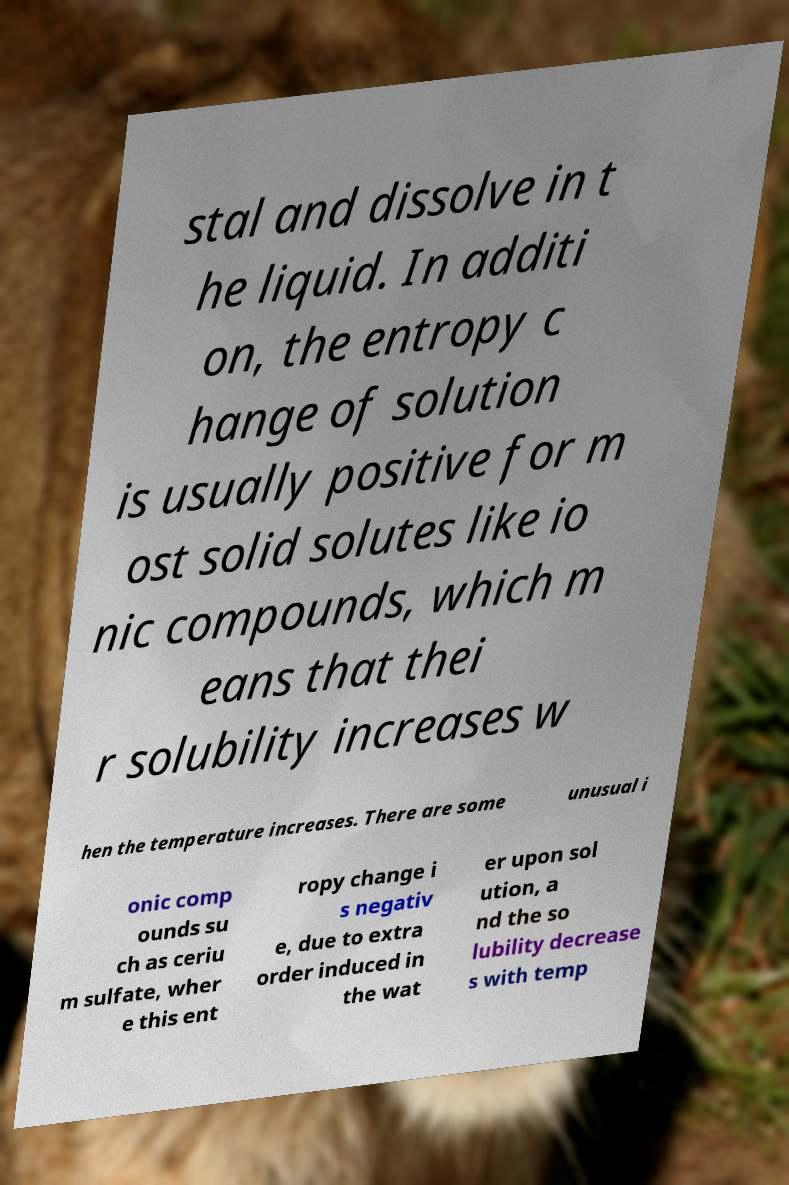I need the written content from this picture converted into text. Can you do that? stal and dissolve in t he liquid. In additi on, the entropy c hange of solution is usually positive for m ost solid solutes like io nic compounds, which m eans that thei r solubility increases w hen the temperature increases. There are some unusual i onic comp ounds su ch as ceriu m sulfate, wher e this ent ropy change i s negativ e, due to extra order induced in the wat er upon sol ution, a nd the so lubility decrease s with temp 